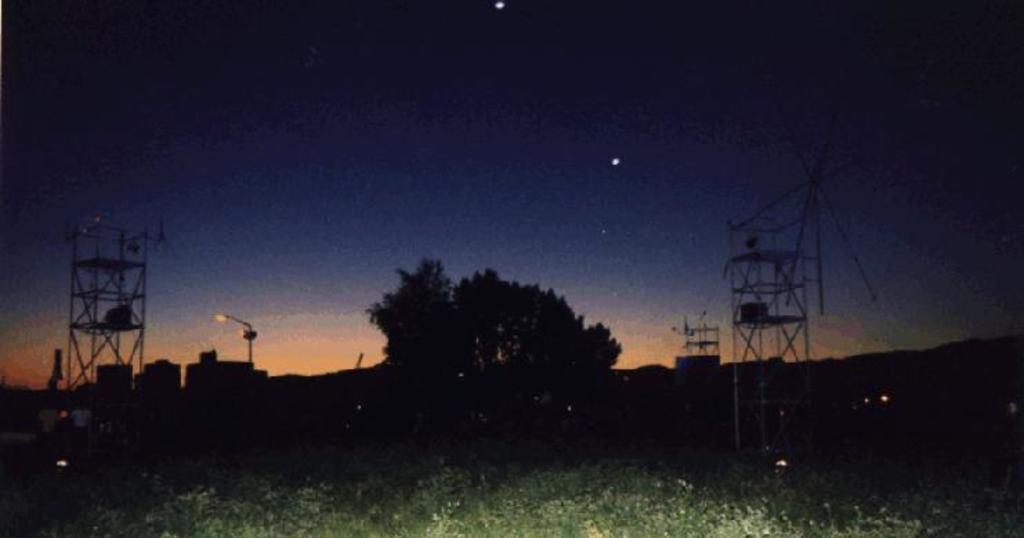What type of plants can be seen in the image? There are green plants in the image. What is the color of the background in the image? The background of the image is dark. Can you describe the light source in the image? There is a light on a pole in the image. What other natural elements are present in the image? There is a tree in the image. What man-made structure can be seen in the image? There is a tower in the image. What part of the natural environment is visible in the image? The sky is visible in the image. What type of eggnog is being served to the visitor in the image? There is no eggnog or visitor present in the image. What action is the visitor performing in the image? There is no visitor present in the image, so no action can be observed. 